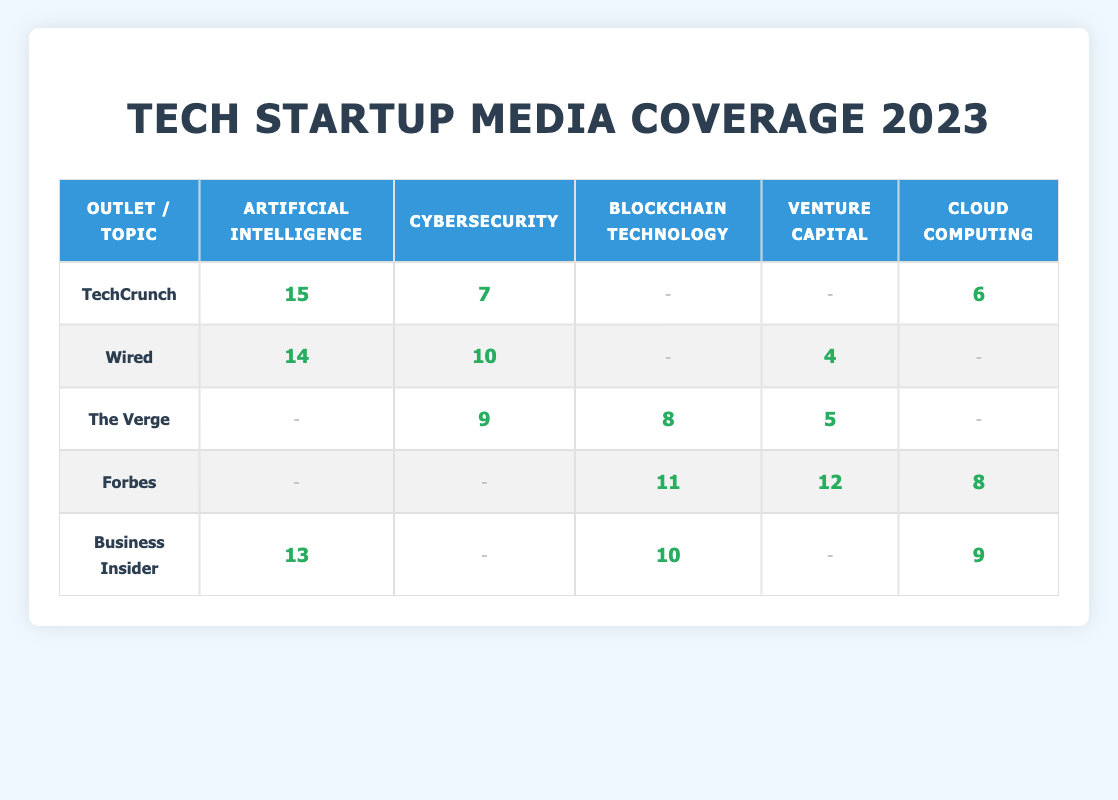What outlet had the highest coverage count for Artificial Intelligence? In the table, TechCrunch has a coverage count of 15 for Artificial Intelligence, which is the highest when compared to Wired (14), Business Insider (13), and others.
Answer: TechCrunch How many topics did Wired cover in total? By reviewing the table, Wired covered Artificial Intelligence (14), Cybersecurity (10), Venture Capital (4), and did not cover Blockchain Technology or Cloud Computing. Adding these gives 14 + 10 + 4 = 28.
Answer: 28 Did The Verge report on Cloud Computing? The table shows that The Verge has a “no data” entry for Cloud Computing, indicating they did not report on this topic at all.
Answer: No Which outlet covered the lowest number of topics and what were they? Forbes covered three topics: Blockchain Technology (11), Venture Capital (12), and Cloud Computing (8). The Verge covered three topics too: Cybersecurity (9), Blockchain Technology (8), and Venture Capital (5). Comparing all the entries, Wired covered four topics but not Blockchain or Cloud Computing. The outlet with the lowest coverage on average is The Verge as its coverage count varies less.
Answer: The Verge What is the total coverage count for Cybersecurity across all outlets? The coverage count for Cybersecurity can be found by adding TechCrunch (7), Wired (10), The Verge (9), Forbes (0), and Business Insider (0). So, calculating gives us 7 + 10 + 9 + 0 + 0 = 26.
Answer: 26 How many total coverage counts did Business Insider achieve? Business Insider covered Artificial Intelligence (13), Blockchain Technology (10), and Cloud Computing (9). Adding these values yields 13 + 10 + 9 = 32.
Answer: 32 Is it true that Forbes had more coverage on Venture Capital than Cybersecurity? Forbes has zero coverage on Cybersecurity and a count of 12 for Venture Capital. Therefore, it is true that Forbes had more coverage on Venture Capital than Cybersecurity.
Answer: Yes Which outlet produced more coverage for Cloud Computing, TechCrunch or Business Insider? TechCrunch has a coverage count of 6 for Cloud Computing, while Business Insider has 9. Therefore, Business Insider produced more coverage for Cloud Computing than TechCrunch.
Answer: Business Insider What is the average coverage count for the topic Blockchain Technology? Adding the coverage counts for Blockchain Technology gives us 8 (The Verge) + 11 (Forbes) + 10 (Business Insider) = 29. There are three entries, and dividing the sum by three gives us an average of 29/3, which equals approximately 9.67.
Answer: 9.67 